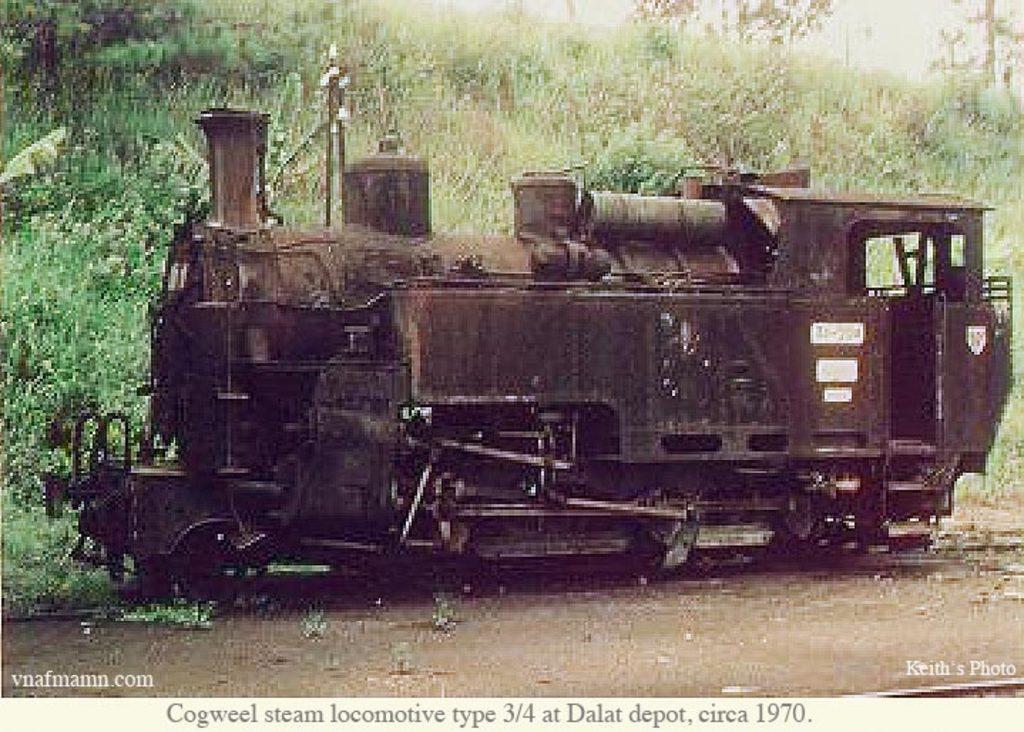Could you give a brief overview of what you see in this image? In this image we can see a train engine and there are some trees and plants in the background. 